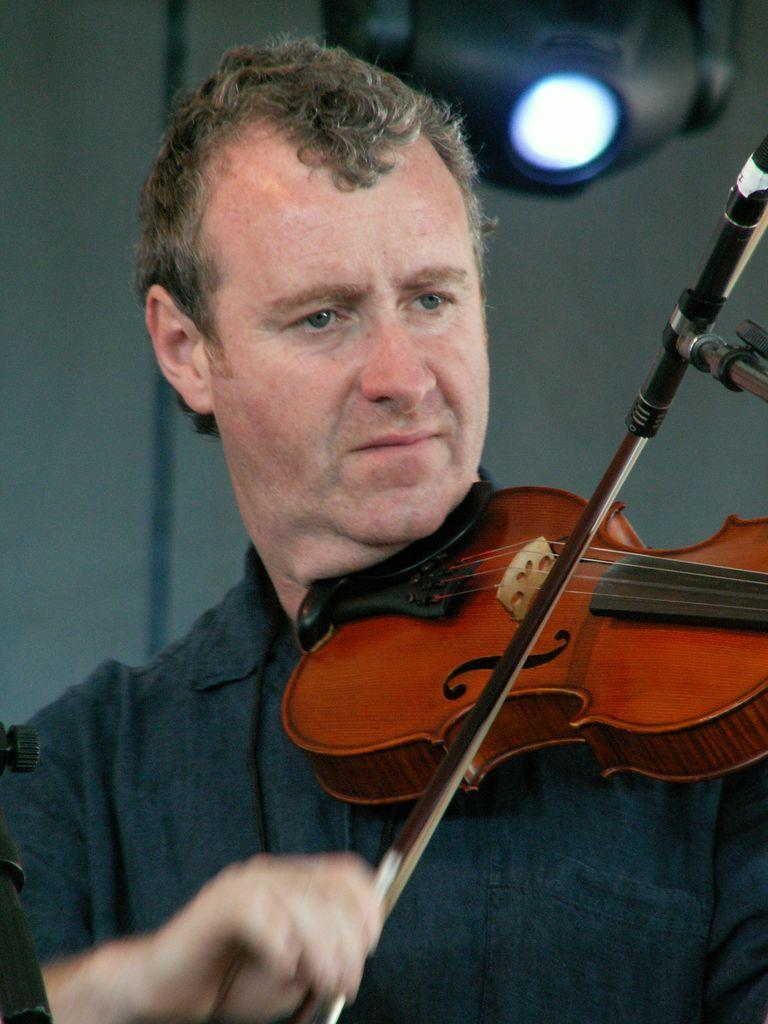What is the person in the image holding? The person is holding a guitar. What is the person doing with the guitar? The person is playing the guitar. What color is the shirt the person is wearing? The person is wearing a black shirt. What can be seen on the wall behind the person? There is a white color wall in the background. What else is visible in the background? There are lights visible in the background. What type of class is the person attending in the image? There is no indication of a class in the image; it shows a person playing a guitar. How much growth has the person experienced since the last time they were photographed? There is no information about the person's growth in the image, as it focuses on the person playing the guitar. 